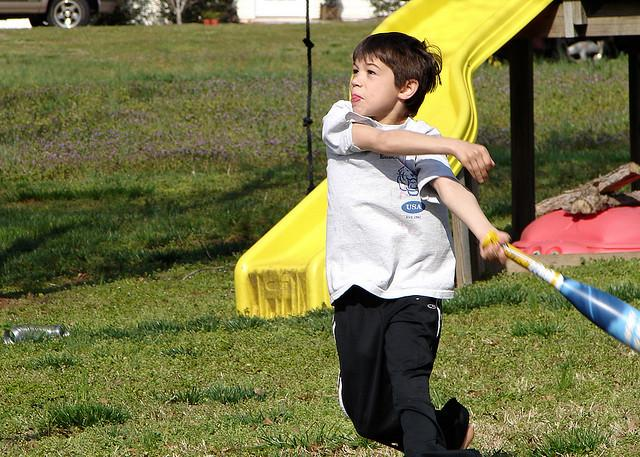What is the boy looking at? Please explain your reasoning. baseball. He looks at the baseball. 